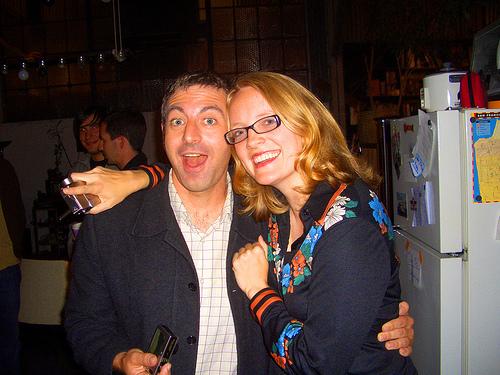What color is the woman wearing?
Quick response, please. Blue. Is the woman wearing glasses?
Give a very brief answer. Yes. Is this couple married?
Give a very brief answer. No. What clothing item on the woman is the same color as the man's shirt?
Short answer required. Shirt. Are there magnets on the refrigerator?
Answer briefly. Yes. Is the man wearing glasses?
Answer briefly. No. Who is wearing glasses?
Give a very brief answer. Woman. What kind of jacket does the man have on?
Quick response, please. Wool. 